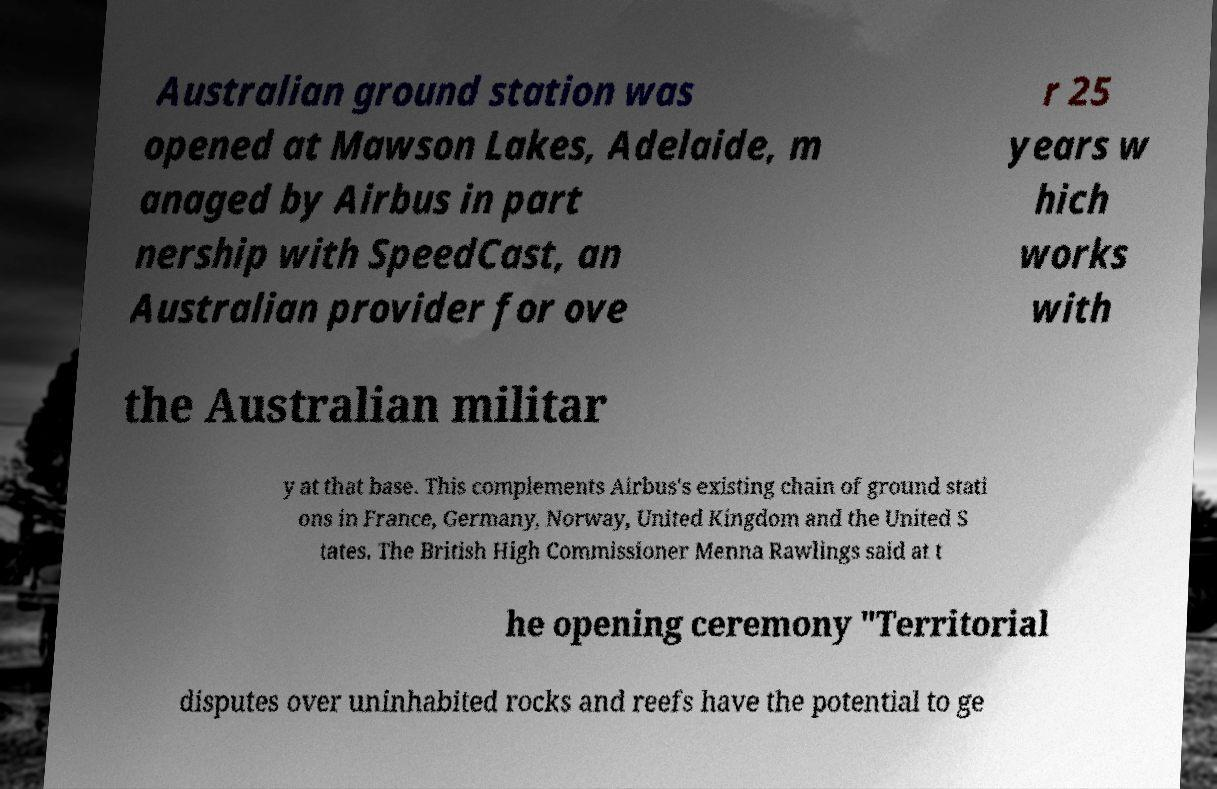There's text embedded in this image that I need extracted. Can you transcribe it verbatim? Australian ground station was opened at Mawson Lakes, Adelaide, m anaged by Airbus in part nership with SpeedCast, an Australian provider for ove r 25 years w hich works with the Australian militar y at that base. This complements Airbus's existing chain of ground stati ons in France, Germany, Norway, United Kingdom and the United S tates. The British High Commissioner Menna Rawlings said at t he opening ceremony "Territorial disputes over uninhabited rocks and reefs have the potential to ge 